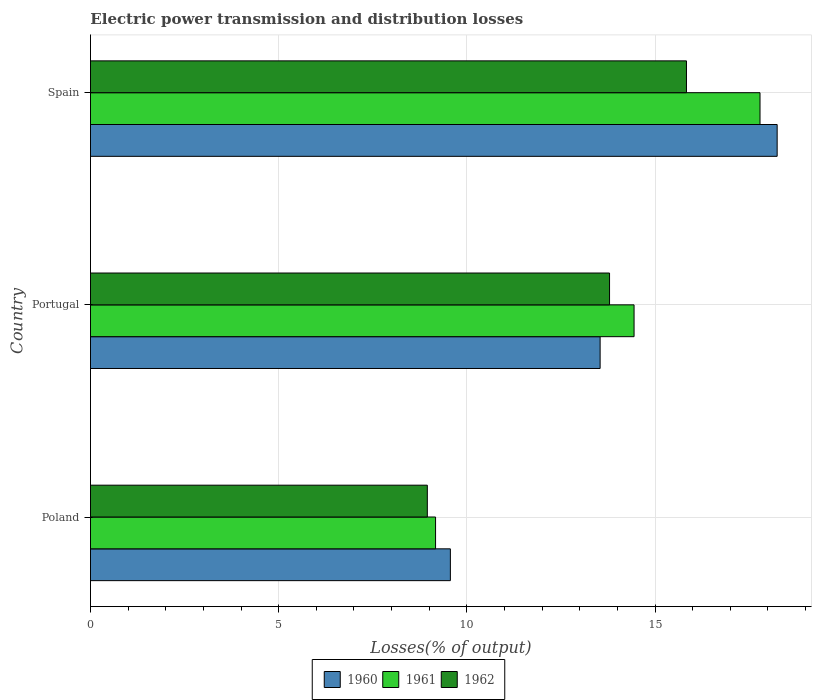How many different coloured bars are there?
Offer a terse response. 3. Are the number of bars on each tick of the Y-axis equal?
Make the answer very short. Yes. How many bars are there on the 3rd tick from the top?
Give a very brief answer. 3. What is the label of the 1st group of bars from the top?
Provide a short and direct response. Spain. In how many cases, is the number of bars for a given country not equal to the number of legend labels?
Make the answer very short. 0. What is the electric power transmission and distribution losses in 1960 in Poland?
Provide a succinct answer. 9.56. Across all countries, what is the maximum electric power transmission and distribution losses in 1960?
Provide a succinct answer. 18.24. Across all countries, what is the minimum electric power transmission and distribution losses in 1961?
Offer a terse response. 9.17. In which country was the electric power transmission and distribution losses in 1962 maximum?
Your answer should be very brief. Spain. In which country was the electric power transmission and distribution losses in 1960 minimum?
Your answer should be very brief. Poland. What is the total electric power transmission and distribution losses in 1960 in the graph?
Provide a succinct answer. 41.35. What is the difference between the electric power transmission and distribution losses in 1961 in Poland and that in Spain?
Provide a succinct answer. -8.62. What is the difference between the electric power transmission and distribution losses in 1962 in Poland and the electric power transmission and distribution losses in 1961 in Spain?
Ensure brevity in your answer.  -8.84. What is the average electric power transmission and distribution losses in 1961 per country?
Provide a succinct answer. 13.8. What is the difference between the electric power transmission and distribution losses in 1961 and electric power transmission and distribution losses in 1960 in Portugal?
Offer a very short reply. 0.9. In how many countries, is the electric power transmission and distribution losses in 1961 greater than 9 %?
Provide a succinct answer. 3. What is the ratio of the electric power transmission and distribution losses in 1961 in Poland to that in Portugal?
Your answer should be very brief. 0.63. Is the electric power transmission and distribution losses in 1960 in Poland less than that in Portugal?
Make the answer very short. Yes. What is the difference between the highest and the second highest electric power transmission and distribution losses in 1961?
Provide a short and direct response. 3.35. What is the difference between the highest and the lowest electric power transmission and distribution losses in 1960?
Your answer should be very brief. 8.68. In how many countries, is the electric power transmission and distribution losses in 1960 greater than the average electric power transmission and distribution losses in 1960 taken over all countries?
Offer a terse response. 1. Is the sum of the electric power transmission and distribution losses in 1961 in Poland and Spain greater than the maximum electric power transmission and distribution losses in 1962 across all countries?
Keep it short and to the point. Yes. What does the 2nd bar from the top in Spain represents?
Provide a short and direct response. 1961. What does the 3rd bar from the bottom in Portugal represents?
Your response must be concise. 1962. How many bars are there?
Your answer should be compact. 9. Are all the bars in the graph horizontal?
Your response must be concise. Yes. What is the difference between two consecutive major ticks on the X-axis?
Keep it short and to the point. 5. Are the values on the major ticks of X-axis written in scientific E-notation?
Your response must be concise. No. Does the graph contain grids?
Provide a short and direct response. Yes. How many legend labels are there?
Provide a short and direct response. 3. How are the legend labels stacked?
Your response must be concise. Horizontal. What is the title of the graph?
Keep it short and to the point. Electric power transmission and distribution losses. Does "1989" appear as one of the legend labels in the graph?
Your answer should be very brief. No. What is the label or title of the X-axis?
Provide a short and direct response. Losses(% of output). What is the label or title of the Y-axis?
Provide a short and direct response. Country. What is the Losses(% of output) in 1960 in Poland?
Keep it short and to the point. 9.56. What is the Losses(% of output) in 1961 in Poland?
Your response must be concise. 9.17. What is the Losses(% of output) in 1962 in Poland?
Offer a terse response. 8.95. What is the Losses(% of output) of 1960 in Portugal?
Keep it short and to the point. 13.54. What is the Losses(% of output) in 1961 in Portugal?
Give a very brief answer. 14.44. What is the Losses(% of output) in 1962 in Portugal?
Keep it short and to the point. 13.79. What is the Losses(% of output) of 1960 in Spain?
Offer a terse response. 18.24. What is the Losses(% of output) in 1961 in Spain?
Your answer should be very brief. 17.79. What is the Losses(% of output) of 1962 in Spain?
Your answer should be very brief. 15.83. Across all countries, what is the maximum Losses(% of output) in 1960?
Your answer should be very brief. 18.24. Across all countries, what is the maximum Losses(% of output) in 1961?
Offer a very short reply. 17.79. Across all countries, what is the maximum Losses(% of output) of 1962?
Your answer should be very brief. 15.83. Across all countries, what is the minimum Losses(% of output) of 1960?
Give a very brief answer. 9.56. Across all countries, what is the minimum Losses(% of output) in 1961?
Ensure brevity in your answer.  9.17. Across all countries, what is the minimum Losses(% of output) of 1962?
Provide a succinct answer. 8.95. What is the total Losses(% of output) in 1960 in the graph?
Offer a terse response. 41.35. What is the total Losses(% of output) in 1961 in the graph?
Give a very brief answer. 41.4. What is the total Losses(% of output) in 1962 in the graph?
Offer a very short reply. 38.58. What is the difference between the Losses(% of output) in 1960 in Poland and that in Portugal?
Your answer should be very brief. -3.98. What is the difference between the Losses(% of output) of 1961 in Poland and that in Portugal?
Your response must be concise. -5.27. What is the difference between the Losses(% of output) of 1962 in Poland and that in Portugal?
Ensure brevity in your answer.  -4.84. What is the difference between the Losses(% of output) of 1960 in Poland and that in Spain?
Offer a very short reply. -8.68. What is the difference between the Losses(% of output) in 1961 in Poland and that in Spain?
Offer a very short reply. -8.62. What is the difference between the Losses(% of output) of 1962 in Poland and that in Spain?
Offer a very short reply. -6.89. What is the difference between the Losses(% of output) of 1960 in Portugal and that in Spain?
Your answer should be compact. -4.7. What is the difference between the Losses(% of output) in 1961 in Portugal and that in Spain?
Ensure brevity in your answer.  -3.35. What is the difference between the Losses(% of output) of 1962 in Portugal and that in Spain?
Give a very brief answer. -2.04. What is the difference between the Losses(% of output) in 1960 in Poland and the Losses(% of output) in 1961 in Portugal?
Your response must be concise. -4.88. What is the difference between the Losses(% of output) in 1960 in Poland and the Losses(% of output) in 1962 in Portugal?
Your answer should be very brief. -4.23. What is the difference between the Losses(% of output) of 1961 in Poland and the Losses(% of output) of 1962 in Portugal?
Provide a short and direct response. -4.62. What is the difference between the Losses(% of output) in 1960 in Poland and the Losses(% of output) in 1961 in Spain?
Your answer should be very brief. -8.23. What is the difference between the Losses(% of output) in 1960 in Poland and the Losses(% of output) in 1962 in Spain?
Offer a very short reply. -6.27. What is the difference between the Losses(% of output) in 1961 in Poland and the Losses(% of output) in 1962 in Spain?
Ensure brevity in your answer.  -6.67. What is the difference between the Losses(% of output) in 1960 in Portugal and the Losses(% of output) in 1961 in Spain?
Offer a terse response. -4.25. What is the difference between the Losses(% of output) in 1960 in Portugal and the Losses(% of output) in 1962 in Spain?
Your answer should be compact. -2.29. What is the difference between the Losses(% of output) in 1961 in Portugal and the Losses(% of output) in 1962 in Spain?
Give a very brief answer. -1.39. What is the average Losses(% of output) of 1960 per country?
Provide a short and direct response. 13.78. What is the average Losses(% of output) of 1961 per country?
Give a very brief answer. 13.8. What is the average Losses(% of output) in 1962 per country?
Your response must be concise. 12.86. What is the difference between the Losses(% of output) in 1960 and Losses(% of output) in 1961 in Poland?
Offer a very short reply. 0.39. What is the difference between the Losses(% of output) in 1960 and Losses(% of output) in 1962 in Poland?
Provide a succinct answer. 0.61. What is the difference between the Losses(% of output) in 1961 and Losses(% of output) in 1962 in Poland?
Offer a terse response. 0.22. What is the difference between the Losses(% of output) of 1960 and Losses(% of output) of 1961 in Portugal?
Provide a succinct answer. -0.9. What is the difference between the Losses(% of output) in 1960 and Losses(% of output) in 1962 in Portugal?
Offer a very short reply. -0.25. What is the difference between the Losses(% of output) of 1961 and Losses(% of output) of 1962 in Portugal?
Offer a very short reply. 0.65. What is the difference between the Losses(% of output) in 1960 and Losses(% of output) in 1961 in Spain?
Your response must be concise. 0.46. What is the difference between the Losses(% of output) in 1960 and Losses(% of output) in 1962 in Spain?
Keep it short and to the point. 2.41. What is the difference between the Losses(% of output) of 1961 and Losses(% of output) of 1962 in Spain?
Give a very brief answer. 1.95. What is the ratio of the Losses(% of output) of 1960 in Poland to that in Portugal?
Provide a succinct answer. 0.71. What is the ratio of the Losses(% of output) of 1961 in Poland to that in Portugal?
Ensure brevity in your answer.  0.63. What is the ratio of the Losses(% of output) in 1962 in Poland to that in Portugal?
Your answer should be very brief. 0.65. What is the ratio of the Losses(% of output) of 1960 in Poland to that in Spain?
Make the answer very short. 0.52. What is the ratio of the Losses(% of output) in 1961 in Poland to that in Spain?
Keep it short and to the point. 0.52. What is the ratio of the Losses(% of output) in 1962 in Poland to that in Spain?
Provide a short and direct response. 0.57. What is the ratio of the Losses(% of output) of 1960 in Portugal to that in Spain?
Offer a very short reply. 0.74. What is the ratio of the Losses(% of output) of 1961 in Portugal to that in Spain?
Give a very brief answer. 0.81. What is the ratio of the Losses(% of output) of 1962 in Portugal to that in Spain?
Your response must be concise. 0.87. What is the difference between the highest and the second highest Losses(% of output) in 1960?
Your response must be concise. 4.7. What is the difference between the highest and the second highest Losses(% of output) in 1961?
Give a very brief answer. 3.35. What is the difference between the highest and the second highest Losses(% of output) in 1962?
Ensure brevity in your answer.  2.04. What is the difference between the highest and the lowest Losses(% of output) in 1960?
Offer a terse response. 8.68. What is the difference between the highest and the lowest Losses(% of output) in 1961?
Ensure brevity in your answer.  8.62. What is the difference between the highest and the lowest Losses(% of output) in 1962?
Your response must be concise. 6.89. 